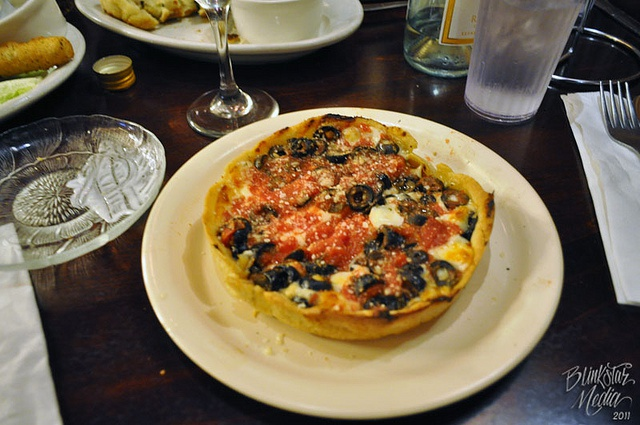Describe the objects in this image and their specific colors. I can see dining table in black, darkgray, tan, and gray tones, bowl in olive and tan tones, pizza in olive, brown, black, maroon, and orange tones, cup in olive, gray, darkgray, and black tones, and wine glass in olive, black, maroon, and gray tones in this image. 